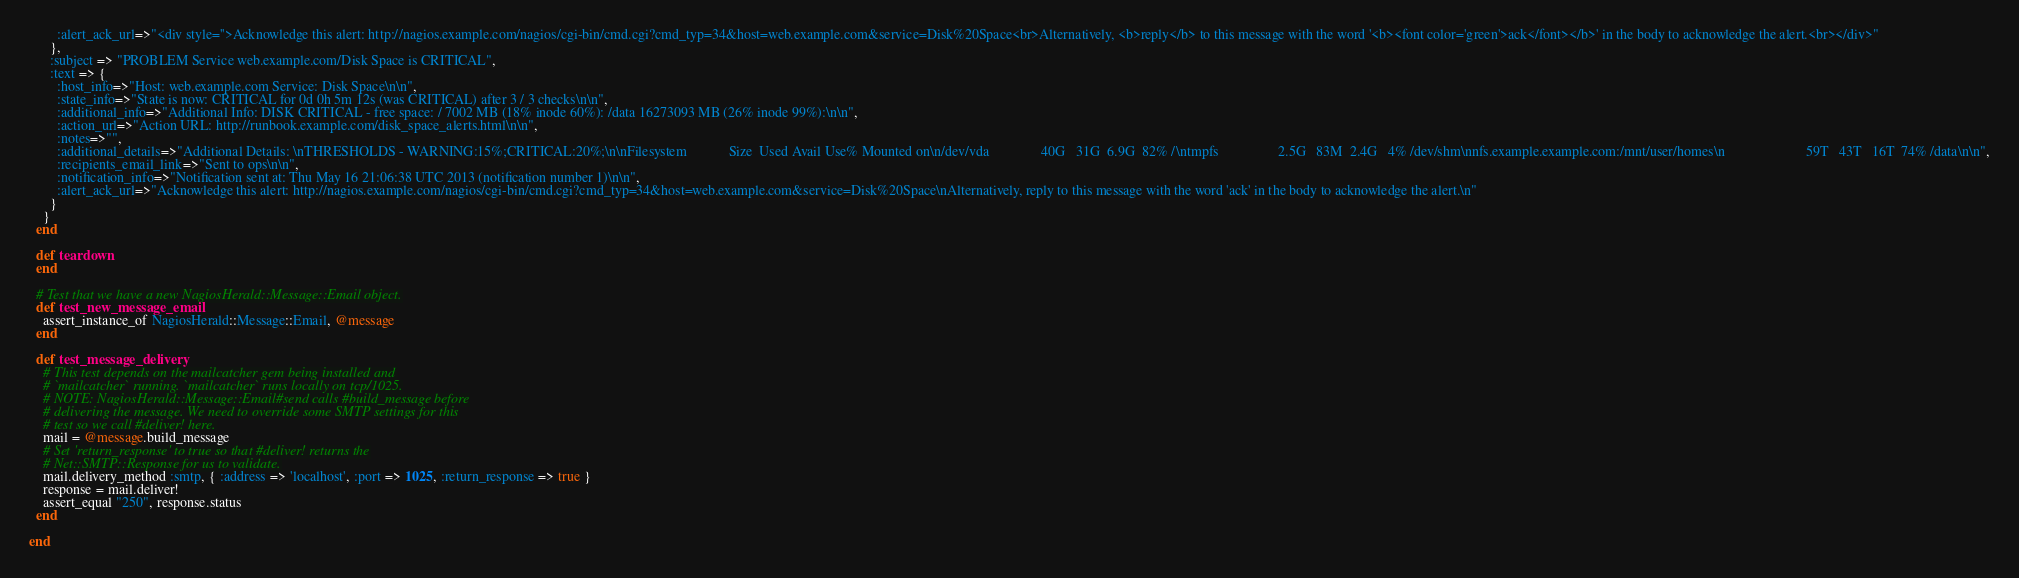Convert code to text. <code><loc_0><loc_0><loc_500><loc_500><_Ruby_>        :alert_ack_url=>"<div style=''>Acknowledge this alert: http://nagios.example.com/nagios/cgi-bin/cmd.cgi?cmd_typ=34&host=web.example.com&service=Disk%20Space<br>Alternatively, <b>reply</b> to this message with the word '<b><font color='green'>ack</font></b>' in the body to acknowledge the alert.<br></div>"
      },
      :subject => "PROBLEM Service web.example.com/Disk Space is CRITICAL",
      :text => {
        :host_info=>"Host: web.example.com Service: Disk Space\n\n",
        :state_info=>"State is now: CRITICAL for 0d 0h 5m 12s (was CRITICAL) after 3 / 3 checks\n\n",
        :additional_info=>"Additional Info: DISK CRITICAL - free space: / 7002 MB (18% inode 60%): /data 16273093 MB (26% inode 99%):\n\n",
        :action_url=>"Action URL: http://runbook.example.com/disk_space_alerts.html\n\n",
        :notes=>"",
        :additional_details=>"Additional Details: \nTHRESHOLDS - WARNING:15%;CRITICAL:20%;\n\nFilesystem            Size  Used Avail Use% Mounted on\n/dev/vda               40G   31G  6.9G  82% /\ntmpfs                 2.5G   83M  2.4G   4% /dev/shm\nnfs.example.example.com:/mnt/user/homes\n                       59T   43T   16T  74% /data\n\n",
        :recipients_email_link=>"Sent to ops\n\n",
        :notification_info=>"Notification sent at: Thu May 16 21:06:38 UTC 2013 (notification number 1)\n\n",
        :alert_ack_url=>"Acknowledge this alert: http://nagios.example.com/nagios/cgi-bin/cmd.cgi?cmd_typ=34&host=web.example.com&service=Disk%20Space\nAlternatively, reply to this message with the word 'ack' in the body to acknowledge the alert.\n"
      }
    }
  end

  def teardown
  end

  # Test that we have a new NagiosHerald::Message::Email object.
  def test_new_message_email
    assert_instance_of NagiosHerald::Message::Email, @message
  end

  def test_message_delivery
    # This test depends on the mailcatcher gem being installed and
    # `mailcatcher` running. `mailcatcher` runs locally on tcp/1025.
    # NOTE: NagiosHerald::Message::Email#send calls #build_message before
    # delivering the message. We need to override some SMTP settings for this
    # test so we call #deliver! here.
    mail = @message.build_message
    # Set 'return_response' to true so that #deliver! returns the
    # Net::SMTP::Response for us to validate.
    mail.delivery_method :smtp, { :address => 'localhost', :port => 1025, :return_response => true }
    response = mail.deliver!
    assert_equal "250", response.status
  end

end

</code> 